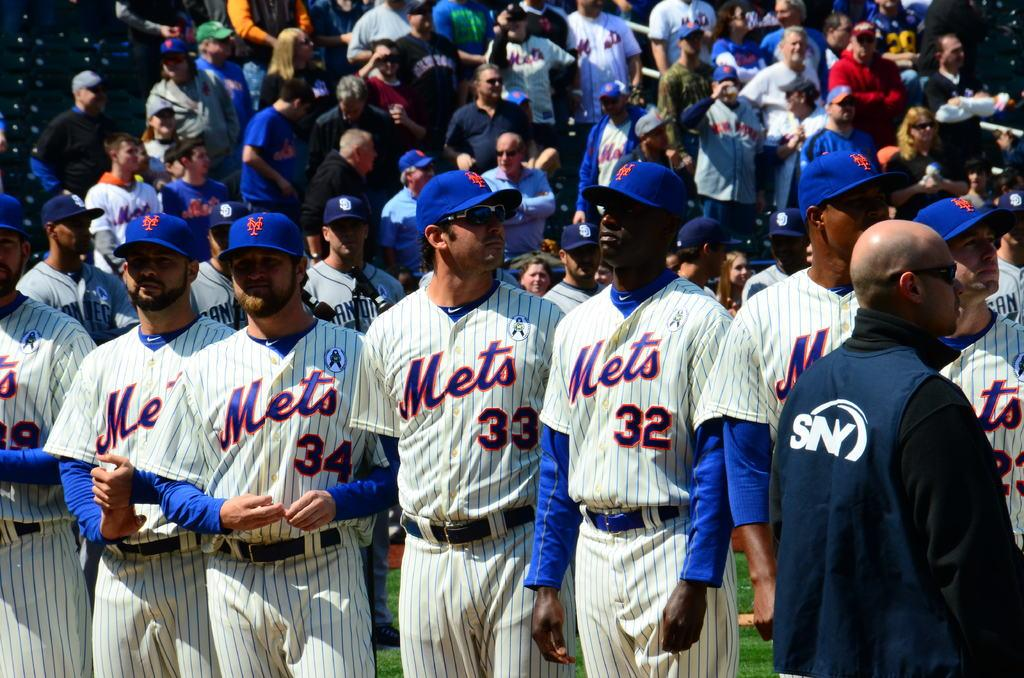<image>
Offer a succinct explanation of the picture presented. A team is lined up with Mets jerseys on. 